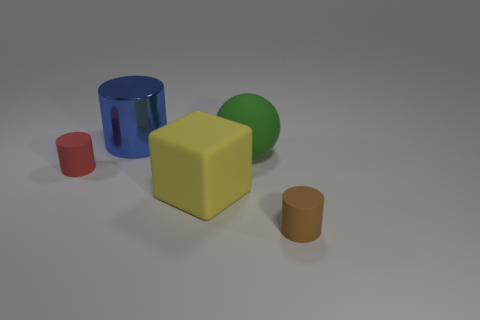There is a small rubber thing that is to the right of the big blue metal object; does it have the same shape as the tiny object that is left of the block? Yes, the small rubber object to the right of the sizable blue cylinder is cylindrical, similar to the tiny brown cylinder located to the left of the yellow block. Both objects share the cylindrical shape despite their differences in size and color. 